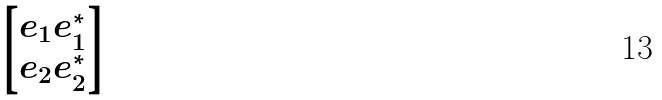Convert formula to latex. <formula><loc_0><loc_0><loc_500><loc_500>\begin{bmatrix} e _ { 1 } e _ { 1 } ^ { * } \\ e _ { 2 } e _ { 2 } ^ { * } \end{bmatrix}</formula> 